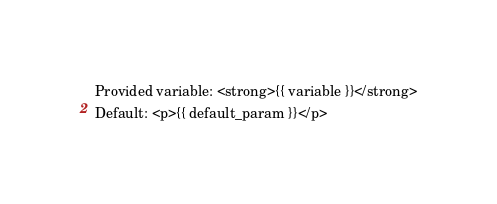Convert code to text. <code><loc_0><loc_0><loc_500><loc_500><_HTML_>Provided variable: <strong>{{ variable }}</strong>
Default: <p>{{ default_param }}</p>
</code> 